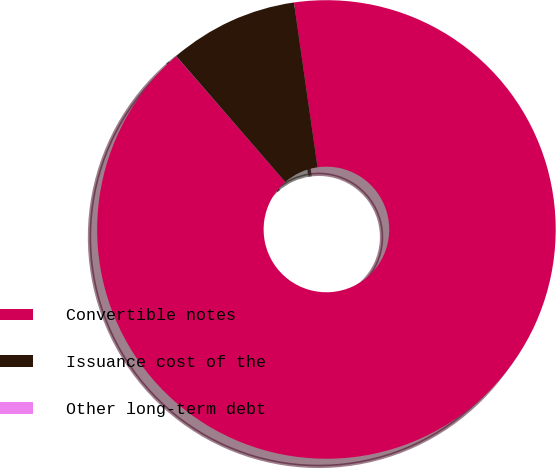<chart> <loc_0><loc_0><loc_500><loc_500><pie_chart><fcel>Convertible notes<fcel>Issuance cost of the<fcel>Other long-term debt<nl><fcel>90.89%<fcel>9.1%<fcel>0.01%<nl></chart> 